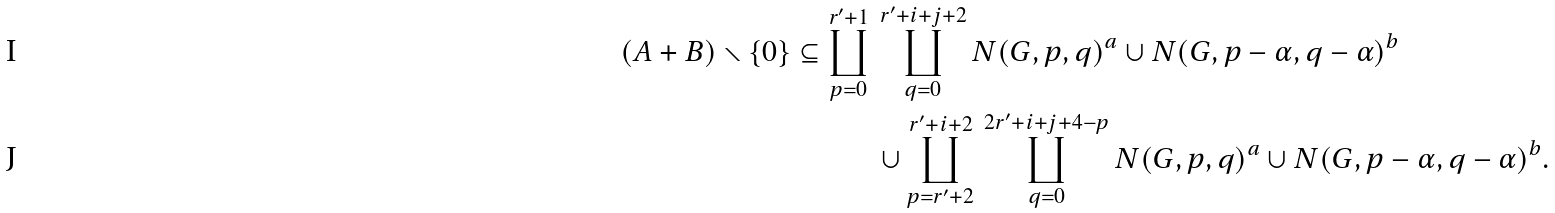Convert formula to latex. <formula><loc_0><loc_0><loc_500><loc_500>( A + B ) \smallsetminus \{ 0 \} \subseteq \coprod _ { p = 0 } ^ { r ^ { \prime } + 1 } \, & \coprod _ { q = 0 } ^ { r ^ { \prime } + i + j + 2 } N ( G , p , q ) ^ { a } \cup N ( G , p - \alpha , q - \alpha ) ^ { b } \\ & \cup \coprod _ { p = r ^ { \prime } + 2 } ^ { r ^ { \prime } + i + 2 } \, \coprod _ { q = 0 } ^ { 2 r ^ { \prime } + i + j + 4 - p } N ( G , p , q ) ^ { a } \cup N ( G , p - \alpha , q - \alpha ) ^ { b } .</formula> 